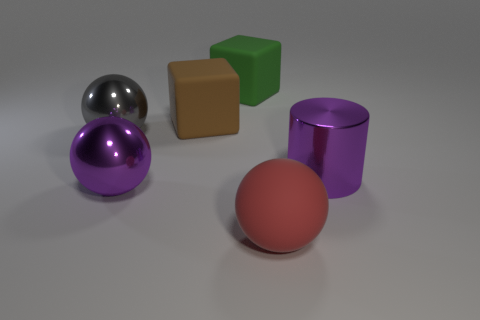Is there a cyan rubber ball of the same size as the green object?
Your answer should be compact. No. Do the big cylinder and the gray sphere have the same material?
Provide a short and direct response. Yes. How many objects are either purple shiny cylinders or purple metal balls?
Give a very brief answer. 2. What size is the purple metallic cylinder?
Give a very brief answer. Large. Are there fewer big gray things than big yellow cylinders?
Your answer should be compact. No. How many objects are the same color as the cylinder?
Your answer should be very brief. 1. There is a large metallic sphere that is in front of the purple shiny cylinder; is it the same color as the metallic cylinder?
Give a very brief answer. Yes. What is the shape of the purple metallic thing that is left of the green cube?
Give a very brief answer. Sphere. Are there any metallic things in front of the shiny object left of the purple sphere?
Offer a terse response. Yes. What number of large objects have the same material as the large cylinder?
Your answer should be compact. 2. 